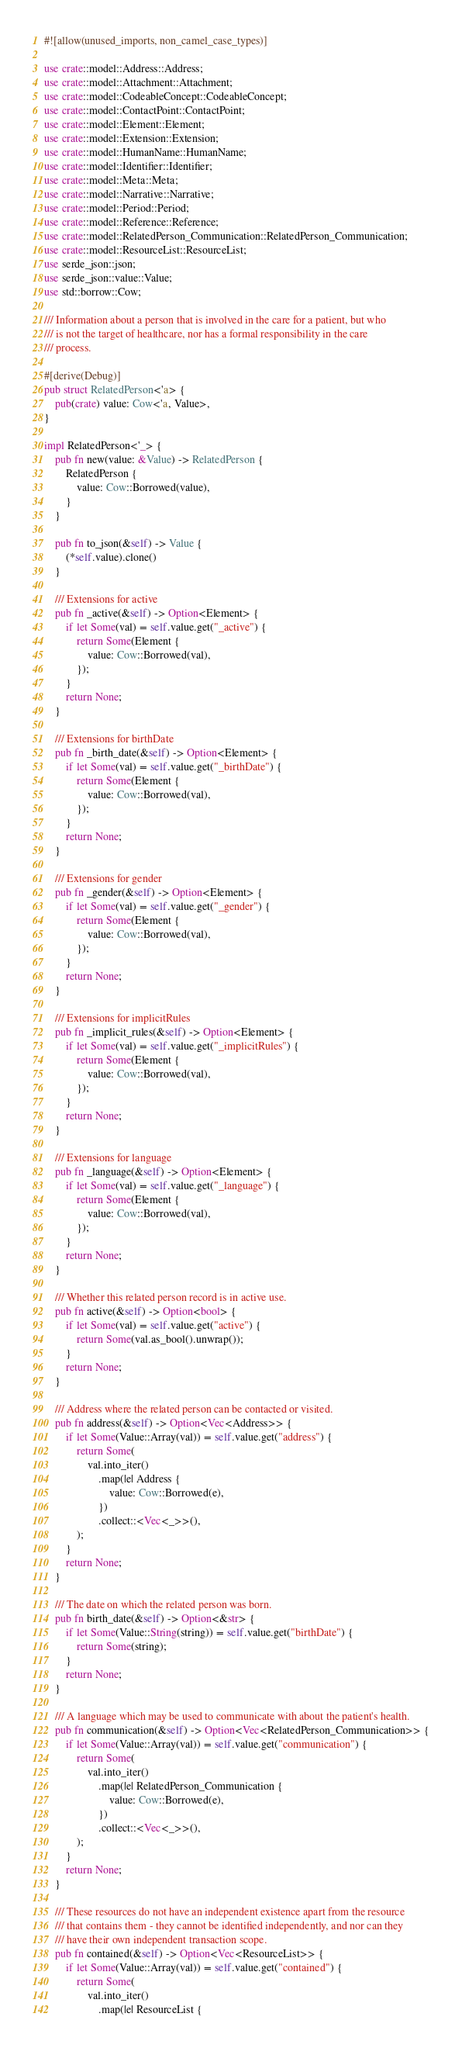Convert code to text. <code><loc_0><loc_0><loc_500><loc_500><_Rust_>#![allow(unused_imports, non_camel_case_types)]

use crate::model::Address::Address;
use crate::model::Attachment::Attachment;
use crate::model::CodeableConcept::CodeableConcept;
use crate::model::ContactPoint::ContactPoint;
use crate::model::Element::Element;
use crate::model::Extension::Extension;
use crate::model::HumanName::HumanName;
use crate::model::Identifier::Identifier;
use crate::model::Meta::Meta;
use crate::model::Narrative::Narrative;
use crate::model::Period::Period;
use crate::model::Reference::Reference;
use crate::model::RelatedPerson_Communication::RelatedPerson_Communication;
use crate::model::ResourceList::ResourceList;
use serde_json::json;
use serde_json::value::Value;
use std::borrow::Cow;

/// Information about a person that is involved in the care for a patient, but who
/// is not the target of healthcare, nor has a formal responsibility in the care
/// process.

#[derive(Debug)]
pub struct RelatedPerson<'a> {
    pub(crate) value: Cow<'a, Value>,
}

impl RelatedPerson<'_> {
    pub fn new(value: &Value) -> RelatedPerson {
        RelatedPerson {
            value: Cow::Borrowed(value),
        }
    }

    pub fn to_json(&self) -> Value {
        (*self.value).clone()
    }

    /// Extensions for active
    pub fn _active(&self) -> Option<Element> {
        if let Some(val) = self.value.get("_active") {
            return Some(Element {
                value: Cow::Borrowed(val),
            });
        }
        return None;
    }

    /// Extensions for birthDate
    pub fn _birth_date(&self) -> Option<Element> {
        if let Some(val) = self.value.get("_birthDate") {
            return Some(Element {
                value: Cow::Borrowed(val),
            });
        }
        return None;
    }

    /// Extensions for gender
    pub fn _gender(&self) -> Option<Element> {
        if let Some(val) = self.value.get("_gender") {
            return Some(Element {
                value: Cow::Borrowed(val),
            });
        }
        return None;
    }

    /// Extensions for implicitRules
    pub fn _implicit_rules(&self) -> Option<Element> {
        if let Some(val) = self.value.get("_implicitRules") {
            return Some(Element {
                value: Cow::Borrowed(val),
            });
        }
        return None;
    }

    /// Extensions for language
    pub fn _language(&self) -> Option<Element> {
        if let Some(val) = self.value.get("_language") {
            return Some(Element {
                value: Cow::Borrowed(val),
            });
        }
        return None;
    }

    /// Whether this related person record is in active use.
    pub fn active(&self) -> Option<bool> {
        if let Some(val) = self.value.get("active") {
            return Some(val.as_bool().unwrap());
        }
        return None;
    }

    /// Address where the related person can be contacted or visited.
    pub fn address(&self) -> Option<Vec<Address>> {
        if let Some(Value::Array(val)) = self.value.get("address") {
            return Some(
                val.into_iter()
                    .map(|e| Address {
                        value: Cow::Borrowed(e),
                    })
                    .collect::<Vec<_>>(),
            );
        }
        return None;
    }

    /// The date on which the related person was born.
    pub fn birth_date(&self) -> Option<&str> {
        if let Some(Value::String(string)) = self.value.get("birthDate") {
            return Some(string);
        }
        return None;
    }

    /// A language which may be used to communicate with about the patient's health.
    pub fn communication(&self) -> Option<Vec<RelatedPerson_Communication>> {
        if let Some(Value::Array(val)) = self.value.get("communication") {
            return Some(
                val.into_iter()
                    .map(|e| RelatedPerson_Communication {
                        value: Cow::Borrowed(e),
                    })
                    .collect::<Vec<_>>(),
            );
        }
        return None;
    }

    /// These resources do not have an independent existence apart from the resource
    /// that contains them - they cannot be identified independently, and nor can they
    /// have their own independent transaction scope.
    pub fn contained(&self) -> Option<Vec<ResourceList>> {
        if let Some(Value::Array(val)) = self.value.get("contained") {
            return Some(
                val.into_iter()
                    .map(|e| ResourceList {</code> 